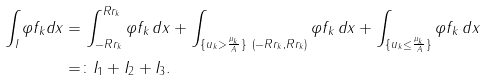Convert formula to latex. <formula><loc_0><loc_0><loc_500><loc_500>\int _ { I } \varphi f _ { k } d x & = \int _ { - R r _ { k } } ^ { R r _ { k } } \varphi f _ { k } \, d x + \int _ { \{ u _ { k } > \frac { \mu _ { k } } { A } \} \ ( - R r _ { k } , R r _ { k } ) } \varphi f _ { k } \, d x + \int _ { \{ u _ { k } \leq \frac { \mu _ { k } } { A } \} } \varphi f _ { k } \, d x \\ & = \colon I _ { 1 } + I _ { 2 } + I _ { 3 } .</formula> 